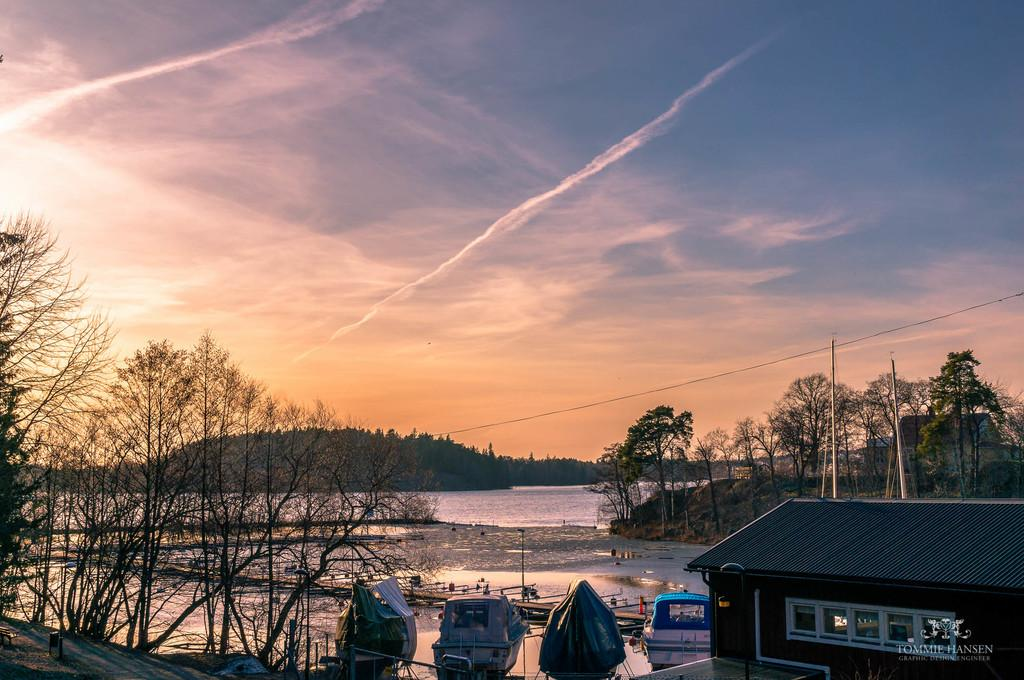What is the primary element visible in the image? There is water in the image. What types of vehicles can be seen in the image? There are boats in the image. What type of structure is present in the image? There is a building in the image. What type of vegetation is visible in the image? There are trees in the image. What type of man-made object is present in the image? There is a wire in the image. What can be seen in the background of the image? There are clouds and the sky visible in the background of the image. Where is the shelf located in the image? There is no shelf present in the image. Can you see the brother of the person taking the picture in the image? There is no person taking the picture, and therefore no brother is visible in the image. 